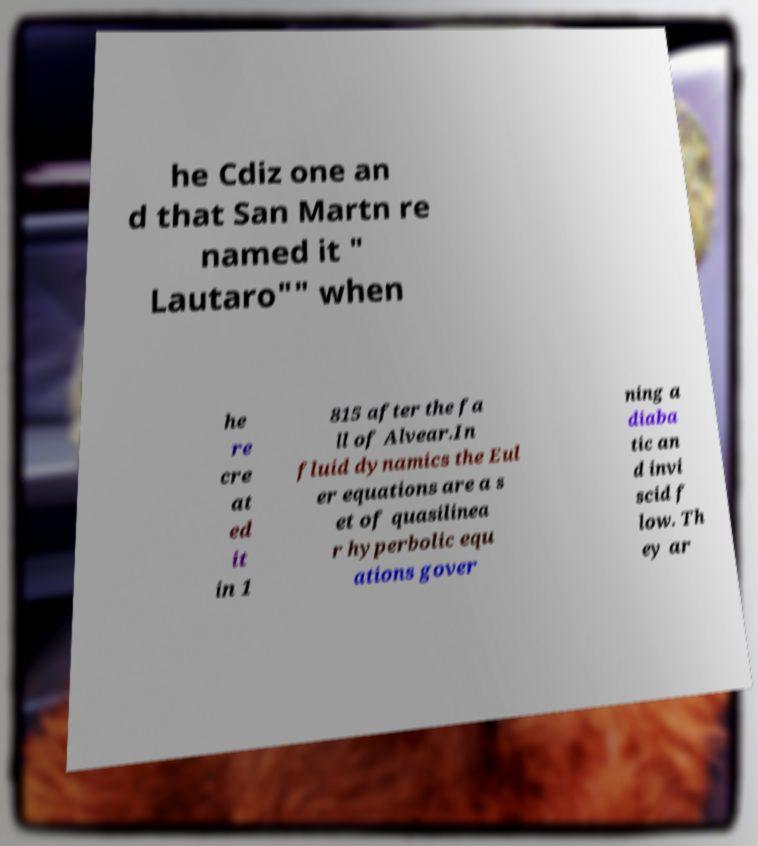Could you extract and type out the text from this image? he Cdiz one an d that San Martn re named it " Lautaro"" when he re cre at ed it in 1 815 after the fa ll of Alvear.In fluid dynamics the Eul er equations are a s et of quasilinea r hyperbolic equ ations gover ning a diaba tic an d invi scid f low. Th ey ar 